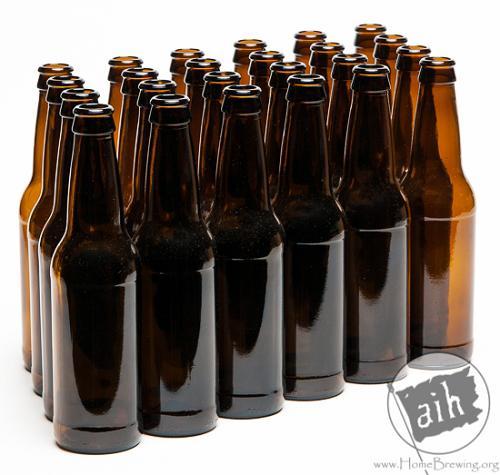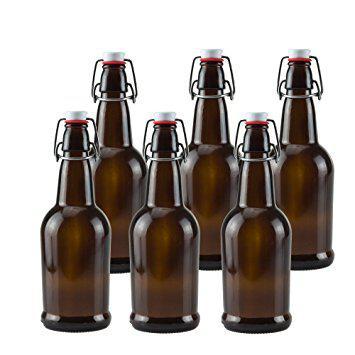The first image is the image on the left, the second image is the image on the right. Given the left and right images, does the statement "One image shows rows of four bottles three deep." hold true? Answer yes or no. No. 